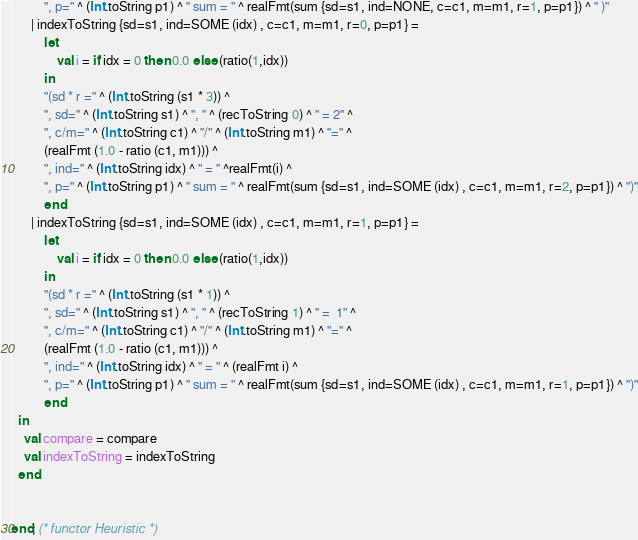<code> <loc_0><loc_0><loc_500><loc_500><_SML_>          ", p=" ^ (Int.toString p1) ^ " sum = " ^ realFmt(sum {sd=s1, ind=NONE, c=c1, m=m1, r=1, p=p1}) ^ " )"
      | indexToString {sd=s1, ind=SOME (idx) , c=c1, m=m1, r=0, p=p1} =
          let
              val i = if idx = 0 then 0.0 else (ratio(1,idx))
          in
          "(sd * r =" ^ (Int.toString (s1 * 3)) ^
          ", sd=" ^ (Int.toString s1) ^ ", " ^ (recToString 0) ^ " = 2" ^
          ", c/m=" ^ (Int.toString c1) ^ "/" ^ (Int.toString m1) ^ "=" ^
          (realFmt (1.0 - ratio (c1, m1))) ^
          ", ind=" ^ (Int.toString idx) ^ " = " ^realFmt(i) ^
          ", p=" ^ (Int.toString p1) ^ " sum = " ^ realFmt(sum {sd=s1, ind=SOME (idx) , c=c1, m=m1, r=2, p=p1}) ^ ")"
          end
      | indexToString {sd=s1, ind=SOME (idx) , c=c1, m=m1, r=1, p=p1} =
          let
              val i = if idx = 0 then 0.0 else (ratio(1,idx))
          in
          "(sd * r =" ^ (Int.toString (s1 * 1)) ^
          ", sd=" ^ (Int.toString s1) ^ ", " ^ (recToString 1) ^ " =  1" ^
          ", c/m=" ^ (Int.toString c1) ^ "/" ^ (Int.toString m1) ^ "=" ^
          (realFmt (1.0 - ratio (c1, m1))) ^
          ", ind=" ^ (Int.toString idx) ^ " = " ^ (realFmt i) ^
          ", p=" ^ (Int.toString p1) ^ " sum = " ^ realFmt(sum {sd=s1, ind=SOME (idx) , c=c1, m=m1, r=1, p=p1}) ^ ")"
          end
  in
    val compare = compare
    val indexToString = indexToString
  end


end; (* functor Heuristic *)</code> 